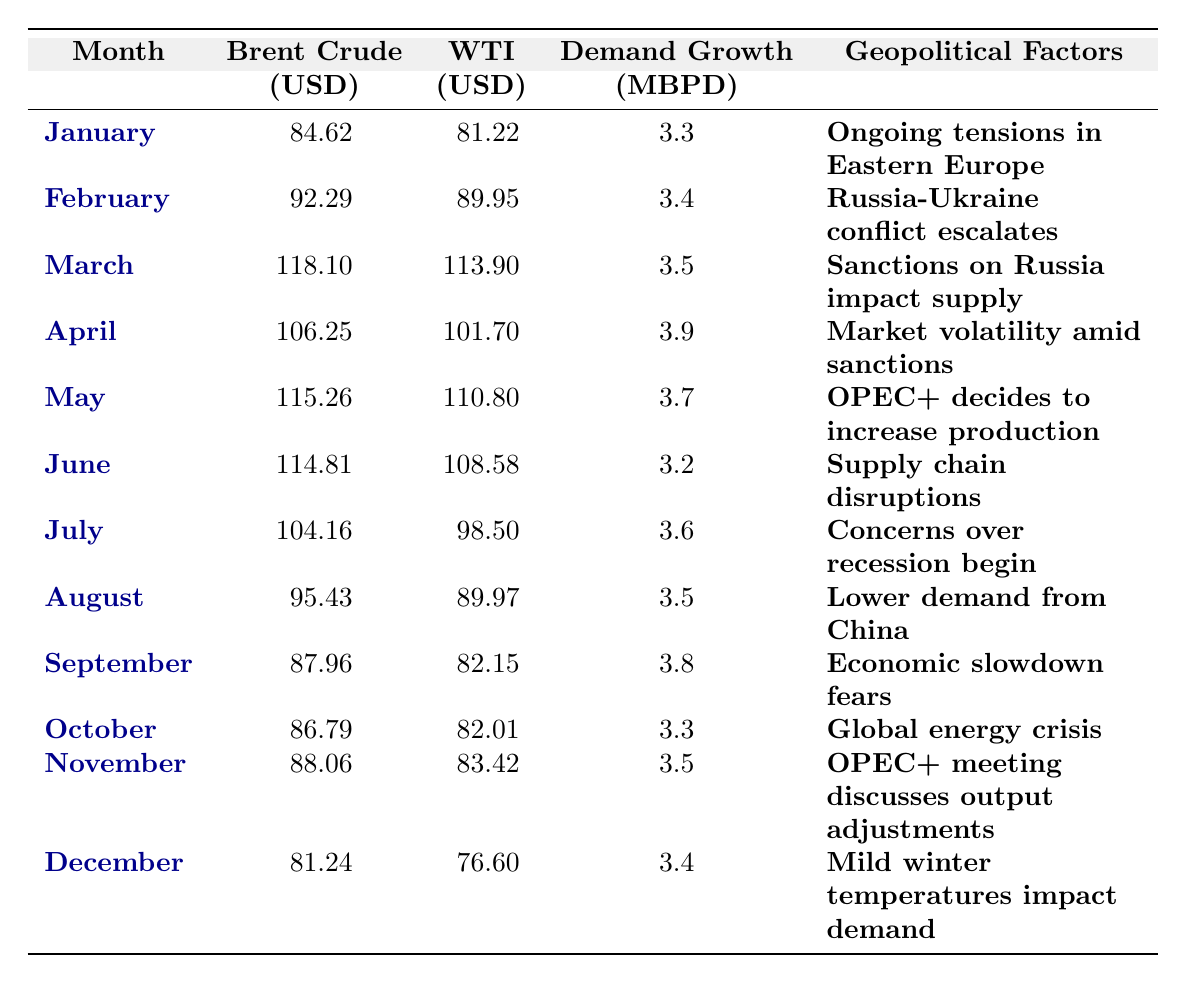What was the highest Brent Crude price in 2022? The highest price listed for Brent Crude in the table is in March at 118.10 USD.
Answer: 118.10 What month had the lowest WTI price in 2022? The lowest WTI price is found in December at 76.60 USD.
Answer: 76.60 What is the average demand growth per month in 2022? To find the average, sum the demand growth values (3.3 + 3.4 + 3.5 + 3.9 + 3.7 + 3.2 + 3.6 + 3.5 + 3.8 + 3.3 + 3.5 + 3.4 = 40.5) and divide by the number of months (12), which gives 40.5 / 12 = 3.375.
Answer: 3.38 Which month saw an increase in Brent Crude price compared to the previous month? Comparing each month to the prior, February (92.29 > 84.62) and March (118.10 > 92.29) both saw increases in Brent Crude prices.
Answer: February and March What was the average difference in price between Brent Crude and WTI in June? In June, Brent Crude was priced at 114.81 USD and WTI at 108.58 USD. The difference is 114.81 - 108.58 = 6.23 USD.
Answer: 6.23 Was there a month where demand growth was above 4 MBPD? Checking the table, all entries for demand growth are below 4 MBPD.
Answer: No What trend can be identified by comparing April and May for Brent Crude prices? April has a Brent Crude price of 106.25 USD, which decreased to 115.26 USD in May, indicating an increase in price from April to May.
Answer: Price increased In which month did OPEC+ decide to increase production, and what were the Brent and WTI prices at that time? OPEC+ decided to increase production in May when the Brent price was 115.26 USD and WTI was 110.80 USD.
Answer: May, 115.26 USD and 110.80 USD What geopolitical factor was associated with the highest Brent Crude price in March? March's Brent price at 118.10 USD was associated with "Sanctions on Russia impact supply."
Answer: Sanctions on Russia impact supply By how much did Brent Crude price fall from March to April? Brent Crude price fell from 118.10 USD in March to 106.25 USD in April, a decrease of 11.85 USD.
Answer: 11.85 